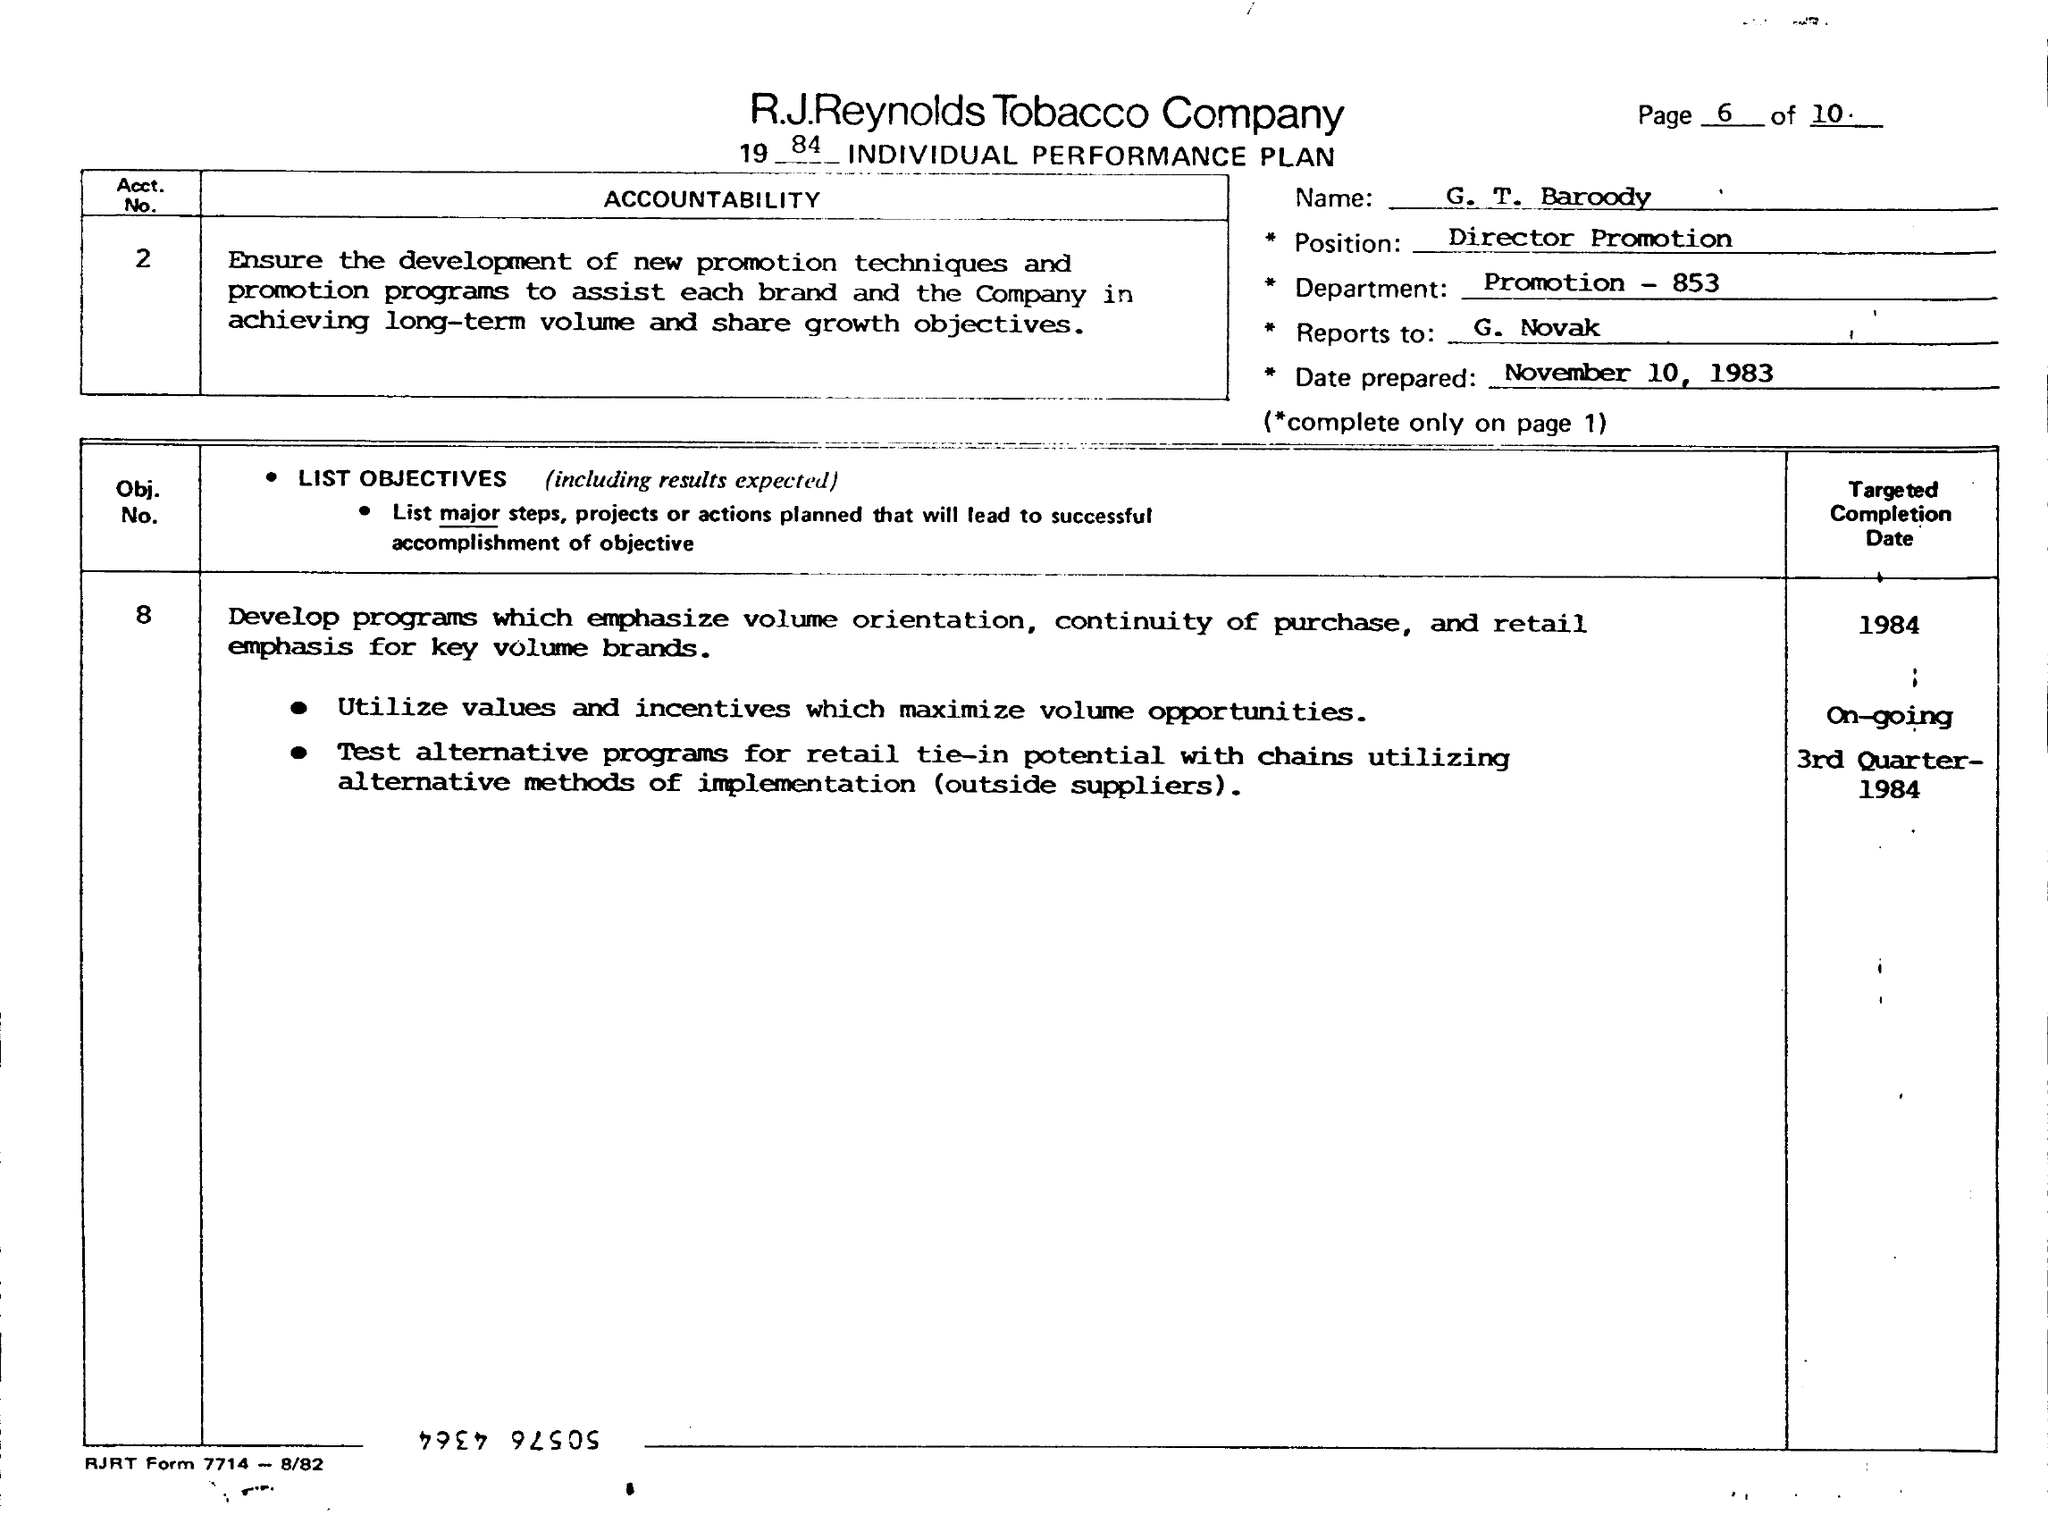Give some essential details in this illustration. The prepared date is November 10, 1983. George T. Barody holds the position of Director of Promotion. 